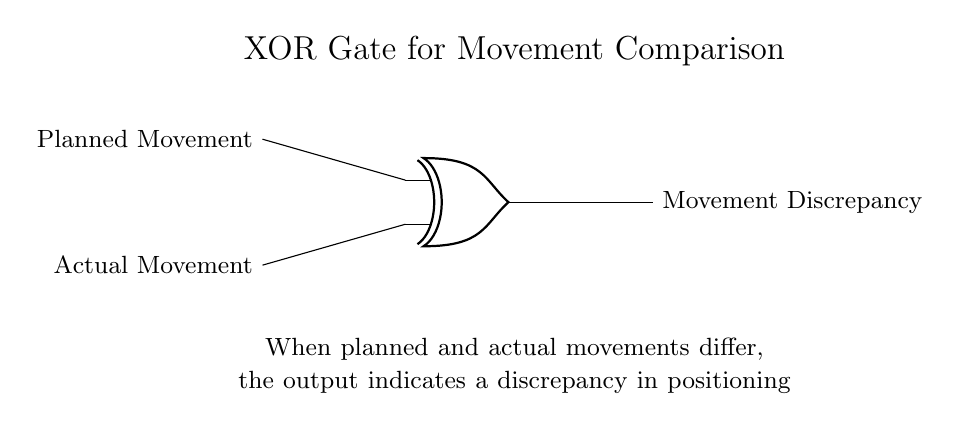What type of logic gate is shown in the circuit? The diagram displays an XOR gate, which is indicated by the label and shape of the gate in the circuit. XOR gates are specifically used in logic circuits to check for differences between two inputs.
Answer: XOR gate What do the two inputs represent in the circuit? The top input is labeled "Planned Movement" and the bottom input is "Actual Movement". These labels clearly define what each input signifies in the context of comparing player movements.
Answer: Planned Movement and Actual Movement What is the output of the circuit called? The output from the XOR gate is labeled as "Movement Discrepancy". This indicates what the result of the XOR operation represents in relation to the inputs provided.
Answer: Movement Discrepancy Under what condition will the output be active? The output will be active when the inputs differ, meaning when either input is true while the other is false. In an XOR gate, this condition activates the output.
Answer: When inputs differ What does the explanation below the gate state about the output? The explanation notes that the output indicates a discrepancy in positioning when the planned and actual movements differ. It further clarifies the function of the logic gate in this application.
Answer: It indicates a discrepancy in positioning How many inputs does the XOR gate in this circuit have? The XOR gate has two inputs, which are the planned and actual movements. The circuit structure allows for two distinct signals to be compared.
Answer: Two inputs 